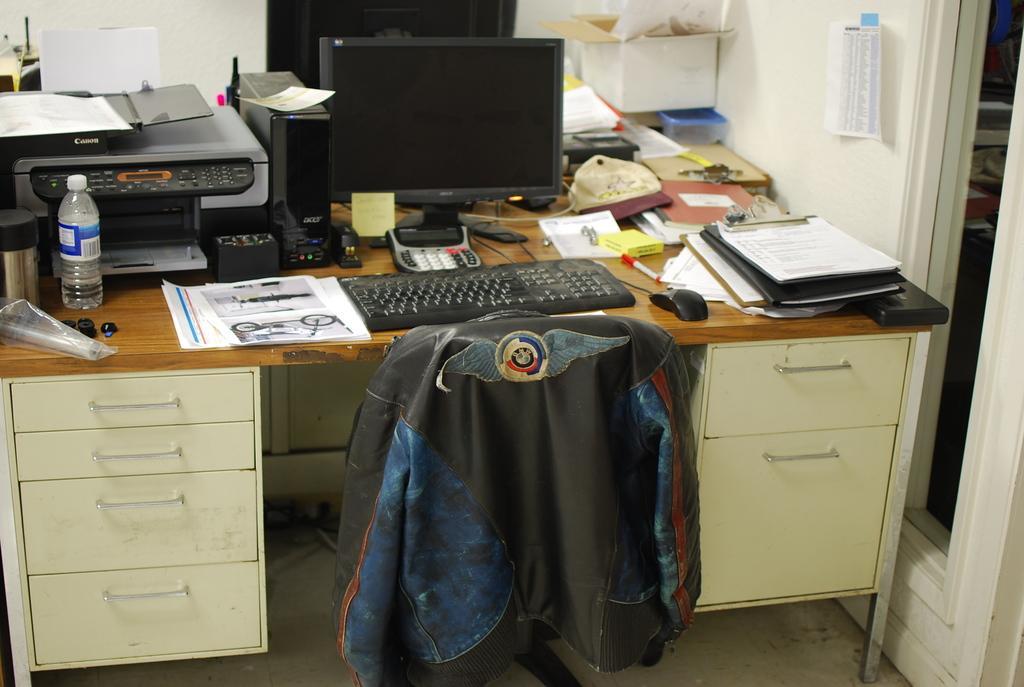Can you describe this image briefly? In this picture we can see a table and on table we have papers, keyboard, mouse, writing pad, monitor, printer, bottle, CPU, boxes, cap and in the background we can see wall, paper and here on chair we have a jacket. 